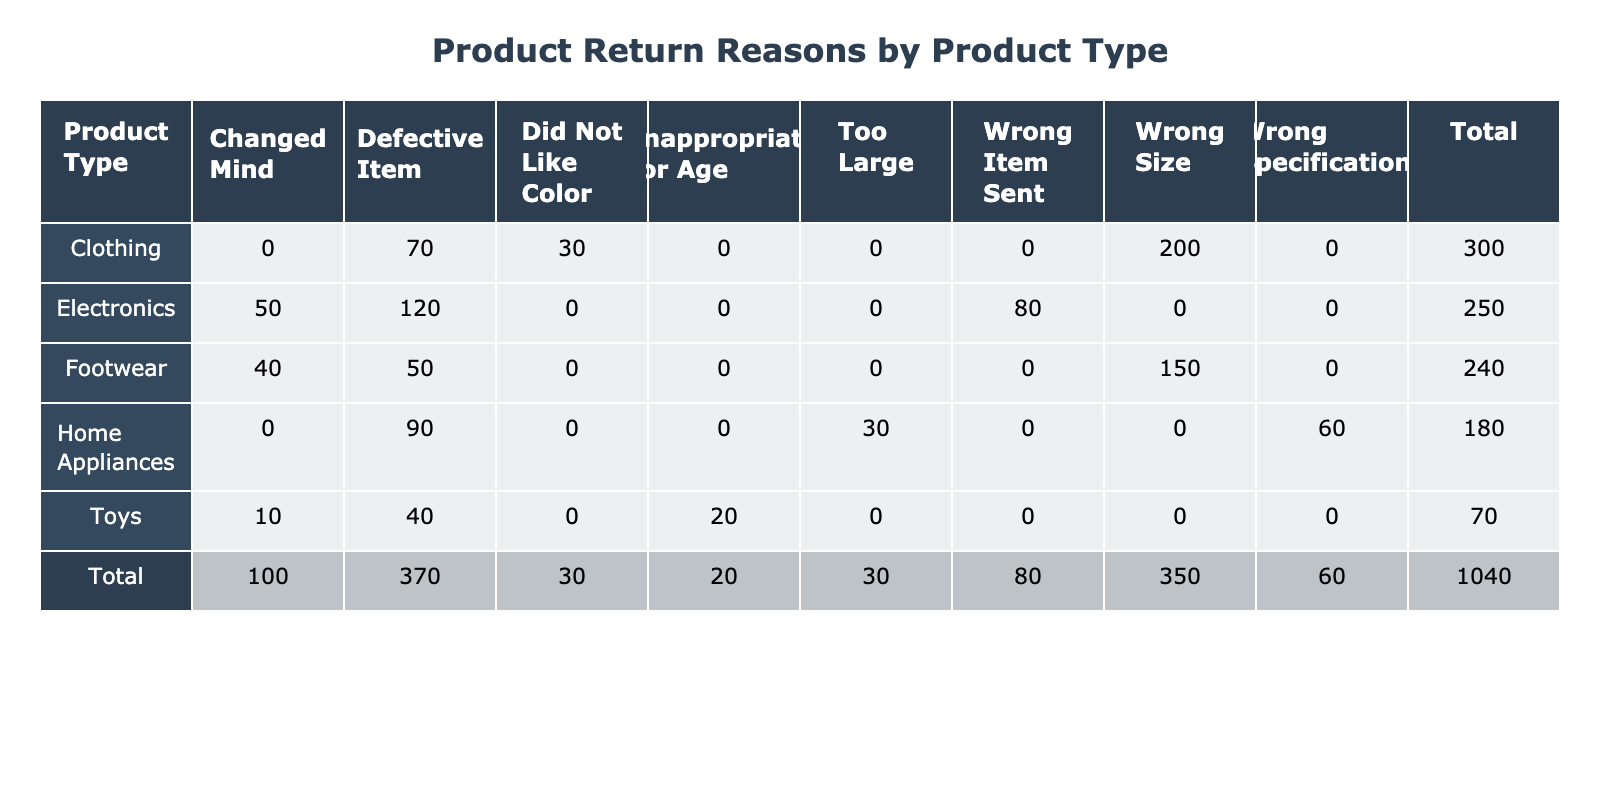What is the return reason with the highest count for Electronics? Looking at the Electronics row, the return reason "Defective Item" has the highest count of 120.
Answer: Defective Item How many Clothing items were returned due to size-related issues? The size-related issues for Clothing include "Wrong Size" (200) and "Defective Item" (70). Adding these counts, we have 200 + 70 = 270.
Answer: 270 Is the total count of returns for Home Appliances greater than 200? The total returns for Home Appliances can be calculated by adding all the counts in that row: Defective Item (90) + Wrong Specifications (60) + Too Large (30) = 180, which is less than 200.
Answer: No Which product type has the highest total returns? To find this, we need to sum the counts for each product type. Electronics: 120 + 80 + 50 = 250, Clothing: 200 + 70 + 30 = 300, Footwear: 150 + 50 + 40 = 240, Home Appliances: 180, Toys: 70. The highest total is Clothing (300).
Answer: Clothing What percentage of all return reasons are due to defective items? First, we need to calculate the total returns across all product types: 120 + 80 + 50 + 200 + 70 + 30 + 150 + 50 + 40 + 90 + 60 + 30 + 40 + 20 + 10 = 1,000. Next, we count the defective items: 120 + 70 + 50 + 90 + 40 = 370. The percentage is (370 / 1000) * 100 = 37%.
Answer: 37% Which return reason has the least count in the Toys category? Looking at the counts for Toys, the return reasons are Defective Item (40), Inappropriate for Age (20), and Changed Mind (10). The least count is for "Changed Mind" with a count of 10.
Answer: Changed Mind How many total returns were attributed to the wrong size across all product types? The return reasons for wrong size include "Wrong Size" in Clothing (200) and Footwear (150). Adding these together gives us 200 + 150 = 350.
Answer: 350 Is it true that Electronics have more returns for "Changed Mind" than Footwear? For Electronics, the count for "Changed Mind" is 50, while for Footwear it is 40. Since 50 is greater than 40, the statement is true.
Answer: Yes 